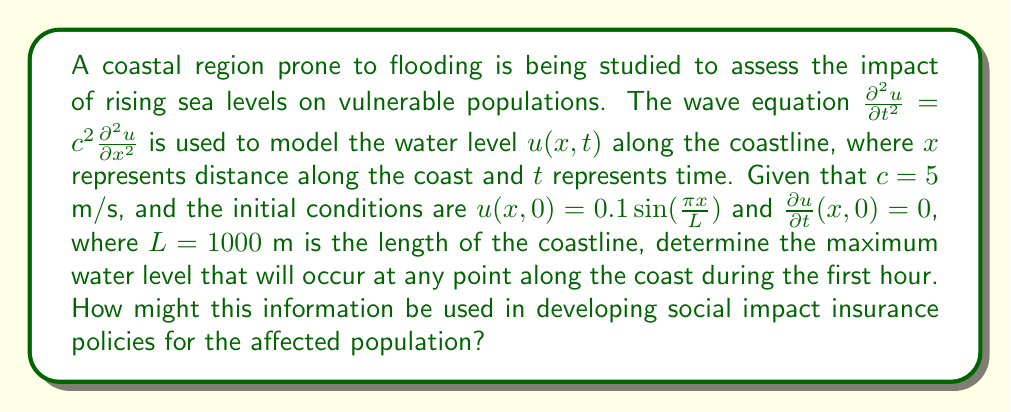Show me your answer to this math problem. To solve this problem, we need to use the general solution of the wave equation and apply the given initial conditions. The steps are as follows:

1) The general solution of the wave equation is given by:

   $u(x,t) = [f(x-ct) + g(x+ct)]$

   where $f$ and $g$ are arbitrary functions.

2) Given the initial conditions, we can determine that:

   $u(x,0) = 0.1 \sin(\frac{\pi x}{L}) = f(x) + g(x)$
   $\frac{\partial u}{\partial t}(x,0) = 0 = c[f'(x) - g'(x)]$

3) From the second condition, we can deduce that $f'(x) = g'(x)$, which means $f(x) = g(x) + C$ where $C$ is a constant. Using this in the first condition:

   $0.1 \sin(\frac{\pi x}{L}) = 2f(x) + C$

   Therefore, $f(x) = 0.05 \sin(\frac{\pi x}{L}) - \frac{C}{2}$ and $g(x) = 0.05 \sin(\frac{\pi x}{L}) + \frac{C}{2}$

4) The complete solution is:

   $u(x,t) = 0.05 \sin(\frac{\pi (x-ct)}{L}) + 0.05 \sin(\frac{\pi (x+ct)}{L})$

5) Using the trigonometric identity for the sum of sines, this can be rewritten as:

   $u(x,t) = 0.1 \sin(\frac{\pi x}{L}) \cos(\frac{\pi ct}{L})$

6) The maximum value of this function occurs when $\sin(\frac{\pi x}{L}) = 1$ and $\cos(\frac{\pi ct}{L}) = 1$. Therefore, the maximum water level is 0.1 m.

7) To check if this maximum occurs within the first hour, we need to verify if there's a time $t \leq 3600$ s where $\cos(\frac{\pi ct}{L}) = 1$. This occurs when $\frac{\pi ct}{L} = 2\pi n$ for any integer $n$.

   The smallest positive $t$ that satisfies this is when $n=1$:
   $t = \frac{2L}{c} = \frac{2(1000)}{5} = 400$ s

   This is less than 3600 s, so the maximum does occur within the first hour.

This information can be used in developing social impact insurance policies by:
1) Identifying areas most at risk of flooding
2) Estimating potential damage to property and infrastructure
3) Determining appropriate insurance premiums based on flood risk
4) Planning evacuation routes and emergency response strategies
5) Informing long-term coastal management and urban planning decisions
Answer: The maximum water level that will occur at any point along the coast during the first hour is 0.1 m. 